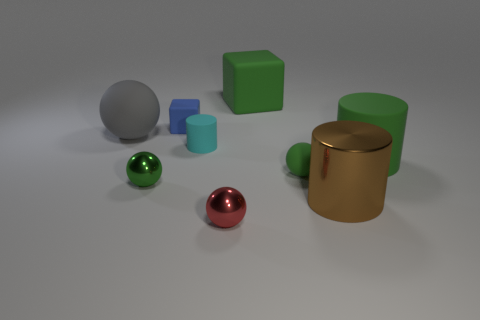Subtract all brown cylinders. How many green spheres are left? 2 Subtract all matte cylinders. How many cylinders are left? 1 Add 1 big red shiny balls. How many objects exist? 10 Subtract 2 spheres. How many spheres are left? 2 Subtract all gray balls. How many balls are left? 3 Subtract all cubes. How many objects are left? 7 Subtract all yellow spheres. Subtract all cyan cubes. How many spheres are left? 4 Subtract 1 gray spheres. How many objects are left? 8 Subtract all big red metallic things. Subtract all metal things. How many objects are left? 6 Add 8 red balls. How many red balls are left? 9 